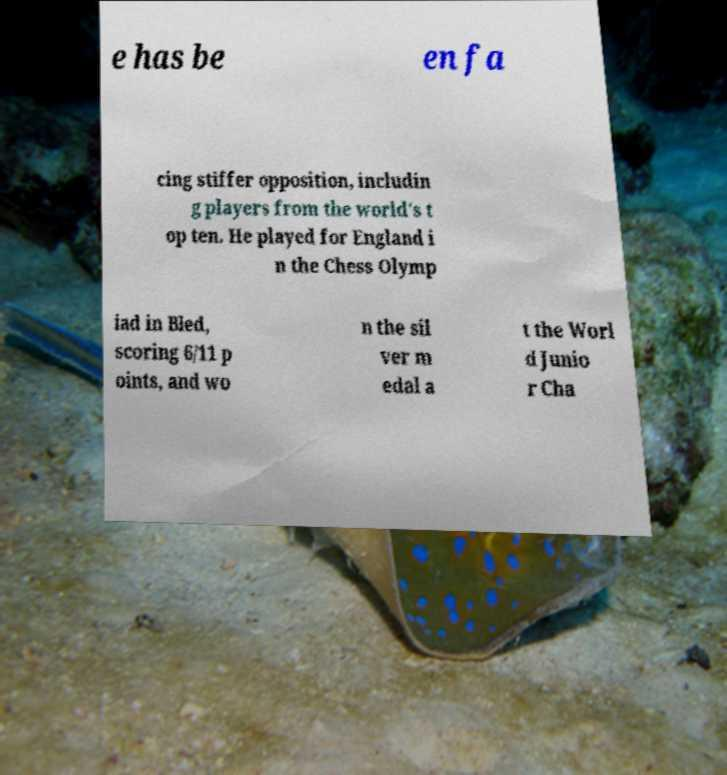Can you read and provide the text displayed in the image?This photo seems to have some interesting text. Can you extract and type it out for me? e has be en fa cing stiffer opposition, includin g players from the world's t op ten. He played for England i n the Chess Olymp iad in Bled, scoring 6/11 p oints, and wo n the sil ver m edal a t the Worl d Junio r Cha 